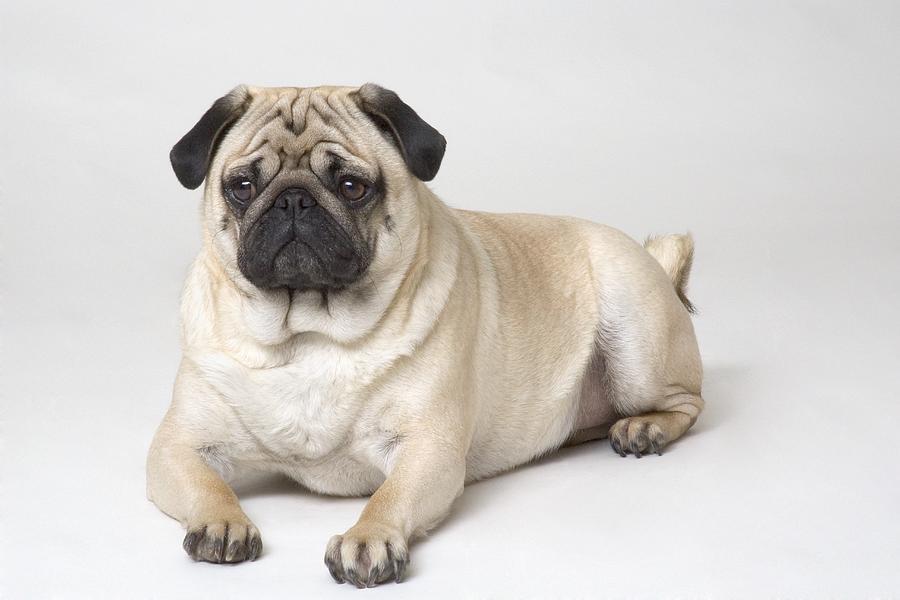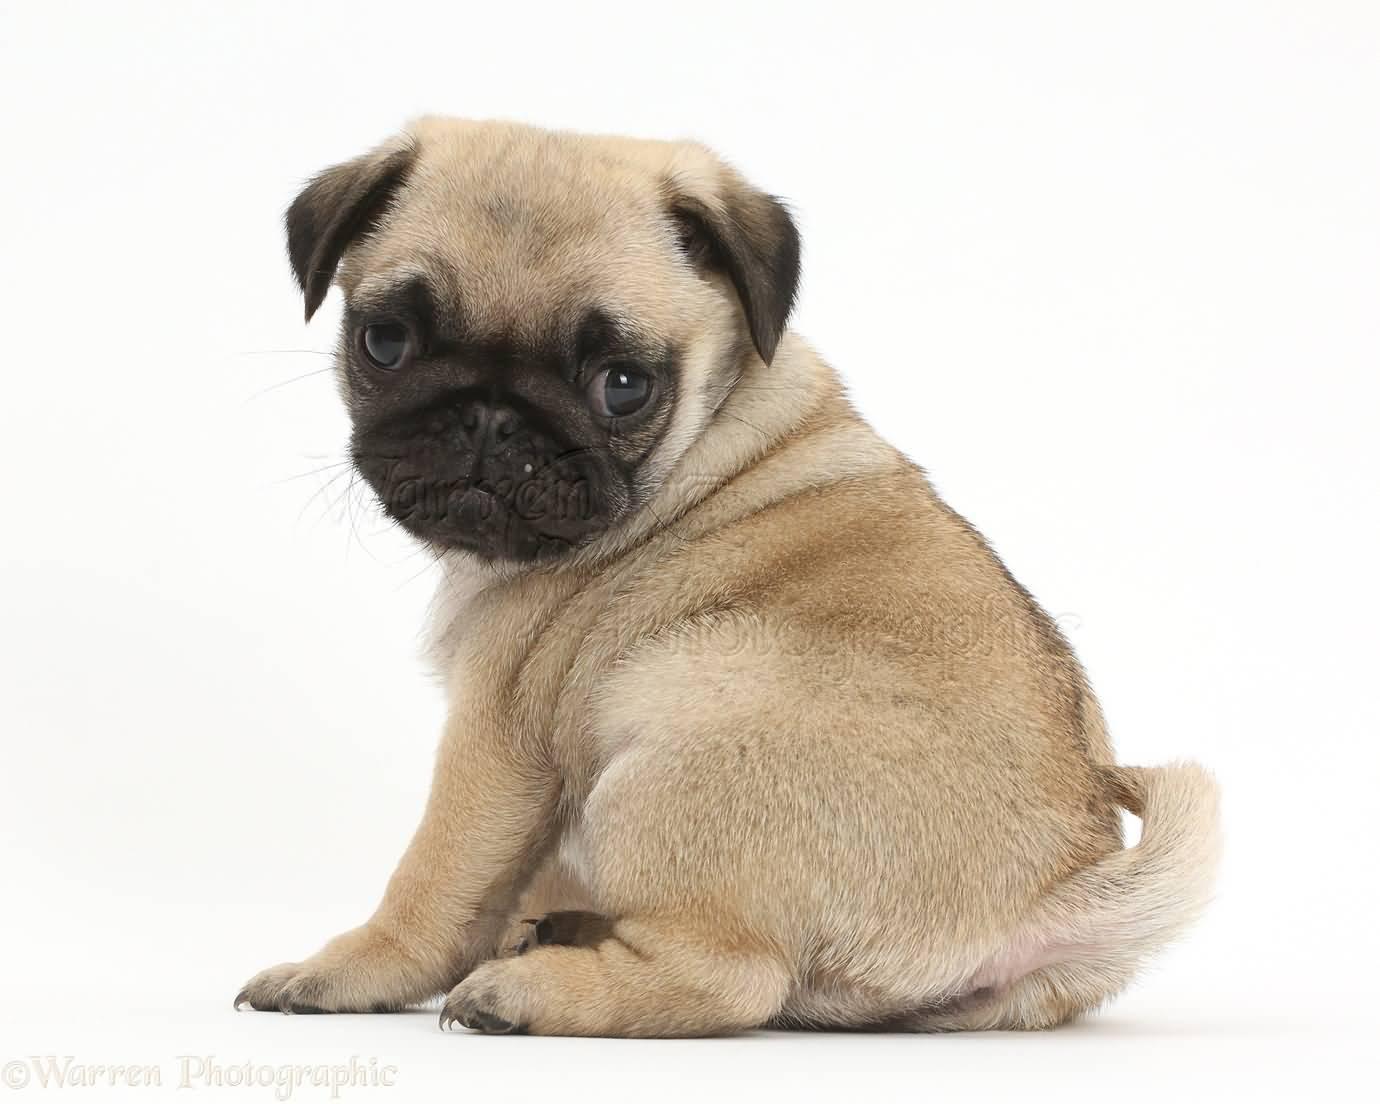The first image is the image on the left, the second image is the image on the right. Analyze the images presented: Is the assertion "In total, two pug tails are visible." valid? Answer yes or no. Yes. 